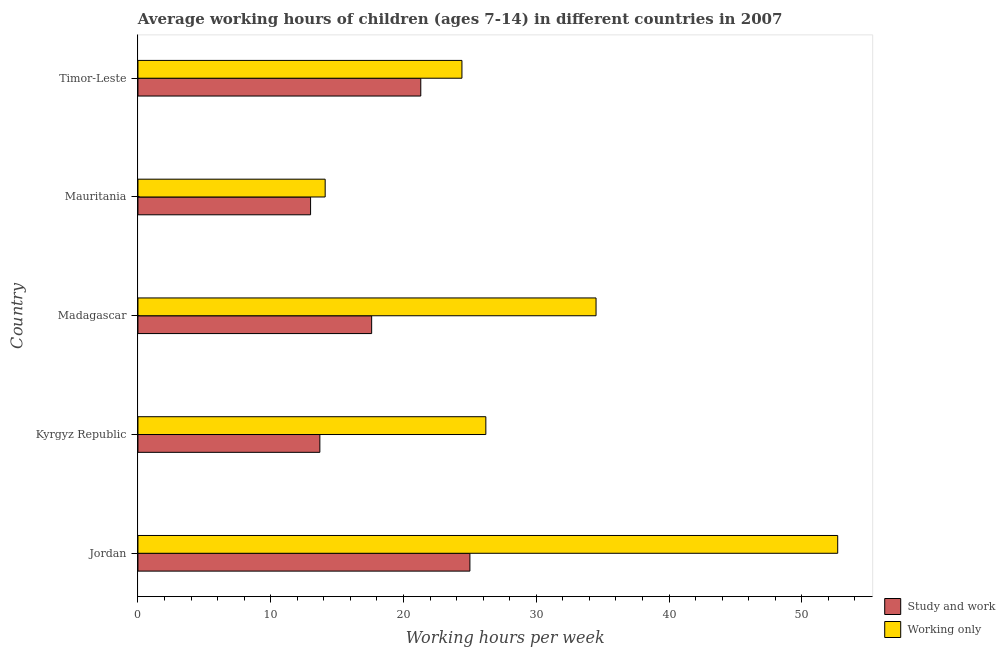How many different coloured bars are there?
Ensure brevity in your answer.  2. How many groups of bars are there?
Ensure brevity in your answer.  5. Are the number of bars per tick equal to the number of legend labels?
Ensure brevity in your answer.  Yes. How many bars are there on the 3rd tick from the top?
Ensure brevity in your answer.  2. How many bars are there on the 3rd tick from the bottom?
Offer a very short reply. 2. What is the label of the 4th group of bars from the top?
Your answer should be compact. Kyrgyz Republic. What is the average working hour of children involved in study and work in Kyrgyz Republic?
Provide a short and direct response. 13.7. Across all countries, what is the maximum average working hour of children involved in only work?
Offer a very short reply. 52.7. In which country was the average working hour of children involved in study and work maximum?
Give a very brief answer. Jordan. In which country was the average working hour of children involved in study and work minimum?
Give a very brief answer. Mauritania. What is the total average working hour of children involved in only work in the graph?
Your response must be concise. 151.9. What is the difference between the average working hour of children involved in study and work in Kyrgyz Republic and the average working hour of children involved in only work in Timor-Leste?
Your answer should be compact. -10.7. What is the average average working hour of children involved in study and work per country?
Offer a terse response. 18.12. What is the difference between the average working hour of children involved in study and work and average working hour of children involved in only work in Jordan?
Your response must be concise. -27.7. In how many countries, is the average working hour of children involved in only work greater than 6 hours?
Provide a succinct answer. 5. What is the ratio of the average working hour of children involved in study and work in Jordan to that in Timor-Leste?
Offer a terse response. 1.17. Is the difference between the average working hour of children involved in only work in Madagascar and Mauritania greater than the difference between the average working hour of children involved in study and work in Madagascar and Mauritania?
Give a very brief answer. Yes. What is the difference between the highest and the second highest average working hour of children involved in study and work?
Offer a very short reply. 3.7. What is the difference between the highest and the lowest average working hour of children involved in only work?
Make the answer very short. 38.6. What does the 2nd bar from the top in Timor-Leste represents?
Keep it short and to the point. Study and work. What does the 2nd bar from the bottom in Jordan represents?
Keep it short and to the point. Working only. How many bars are there?
Your answer should be compact. 10. How many countries are there in the graph?
Offer a very short reply. 5. What is the difference between two consecutive major ticks on the X-axis?
Provide a succinct answer. 10. Are the values on the major ticks of X-axis written in scientific E-notation?
Your answer should be very brief. No. Does the graph contain any zero values?
Make the answer very short. No. How are the legend labels stacked?
Provide a succinct answer. Vertical. What is the title of the graph?
Provide a short and direct response. Average working hours of children (ages 7-14) in different countries in 2007. What is the label or title of the X-axis?
Keep it short and to the point. Working hours per week. What is the Working hours per week in Study and work in Jordan?
Keep it short and to the point. 25. What is the Working hours per week of Working only in Jordan?
Provide a succinct answer. 52.7. What is the Working hours per week of Working only in Kyrgyz Republic?
Ensure brevity in your answer.  26.2. What is the Working hours per week in Study and work in Madagascar?
Keep it short and to the point. 17.6. What is the Working hours per week of Working only in Madagascar?
Provide a succinct answer. 34.5. What is the Working hours per week of Working only in Mauritania?
Ensure brevity in your answer.  14.1. What is the Working hours per week of Study and work in Timor-Leste?
Your answer should be very brief. 21.3. What is the Working hours per week in Working only in Timor-Leste?
Offer a terse response. 24.4. Across all countries, what is the maximum Working hours per week in Study and work?
Your answer should be compact. 25. Across all countries, what is the maximum Working hours per week in Working only?
Offer a terse response. 52.7. Across all countries, what is the minimum Working hours per week in Working only?
Your answer should be compact. 14.1. What is the total Working hours per week in Study and work in the graph?
Your answer should be very brief. 90.6. What is the total Working hours per week of Working only in the graph?
Keep it short and to the point. 151.9. What is the difference between the Working hours per week of Working only in Jordan and that in Kyrgyz Republic?
Your answer should be very brief. 26.5. What is the difference between the Working hours per week in Study and work in Jordan and that in Mauritania?
Make the answer very short. 12. What is the difference between the Working hours per week of Working only in Jordan and that in Mauritania?
Give a very brief answer. 38.6. What is the difference between the Working hours per week in Working only in Jordan and that in Timor-Leste?
Offer a very short reply. 28.3. What is the difference between the Working hours per week of Working only in Kyrgyz Republic and that in Madagascar?
Your answer should be compact. -8.3. What is the difference between the Working hours per week in Working only in Kyrgyz Republic and that in Mauritania?
Ensure brevity in your answer.  12.1. What is the difference between the Working hours per week of Study and work in Kyrgyz Republic and that in Timor-Leste?
Your answer should be compact. -7.6. What is the difference between the Working hours per week in Working only in Kyrgyz Republic and that in Timor-Leste?
Give a very brief answer. 1.8. What is the difference between the Working hours per week of Study and work in Madagascar and that in Mauritania?
Provide a succinct answer. 4.6. What is the difference between the Working hours per week of Working only in Madagascar and that in Mauritania?
Your response must be concise. 20.4. What is the difference between the Working hours per week in Study and work in Madagascar and that in Timor-Leste?
Keep it short and to the point. -3.7. What is the difference between the Working hours per week in Working only in Madagascar and that in Timor-Leste?
Give a very brief answer. 10.1. What is the difference between the Working hours per week in Study and work in Mauritania and that in Timor-Leste?
Offer a terse response. -8.3. What is the difference between the Working hours per week of Working only in Mauritania and that in Timor-Leste?
Your response must be concise. -10.3. What is the difference between the Working hours per week in Study and work in Jordan and the Working hours per week in Working only in Kyrgyz Republic?
Provide a succinct answer. -1.2. What is the difference between the Working hours per week of Study and work in Jordan and the Working hours per week of Working only in Madagascar?
Provide a short and direct response. -9.5. What is the difference between the Working hours per week of Study and work in Jordan and the Working hours per week of Working only in Timor-Leste?
Provide a short and direct response. 0.6. What is the difference between the Working hours per week in Study and work in Kyrgyz Republic and the Working hours per week in Working only in Madagascar?
Give a very brief answer. -20.8. What is the difference between the Working hours per week in Study and work in Madagascar and the Working hours per week in Working only in Mauritania?
Your answer should be compact. 3.5. What is the difference between the Working hours per week in Study and work in Madagascar and the Working hours per week in Working only in Timor-Leste?
Give a very brief answer. -6.8. What is the average Working hours per week in Study and work per country?
Your response must be concise. 18.12. What is the average Working hours per week of Working only per country?
Offer a terse response. 30.38. What is the difference between the Working hours per week of Study and work and Working hours per week of Working only in Jordan?
Ensure brevity in your answer.  -27.7. What is the difference between the Working hours per week of Study and work and Working hours per week of Working only in Madagascar?
Your response must be concise. -16.9. What is the difference between the Working hours per week in Study and work and Working hours per week in Working only in Mauritania?
Make the answer very short. -1.1. What is the difference between the Working hours per week in Study and work and Working hours per week in Working only in Timor-Leste?
Your response must be concise. -3.1. What is the ratio of the Working hours per week of Study and work in Jordan to that in Kyrgyz Republic?
Your answer should be very brief. 1.82. What is the ratio of the Working hours per week in Working only in Jordan to that in Kyrgyz Republic?
Offer a terse response. 2.01. What is the ratio of the Working hours per week of Study and work in Jordan to that in Madagascar?
Provide a short and direct response. 1.42. What is the ratio of the Working hours per week of Working only in Jordan to that in Madagascar?
Offer a terse response. 1.53. What is the ratio of the Working hours per week of Study and work in Jordan to that in Mauritania?
Give a very brief answer. 1.92. What is the ratio of the Working hours per week of Working only in Jordan to that in Mauritania?
Make the answer very short. 3.74. What is the ratio of the Working hours per week in Study and work in Jordan to that in Timor-Leste?
Offer a terse response. 1.17. What is the ratio of the Working hours per week of Working only in Jordan to that in Timor-Leste?
Your answer should be very brief. 2.16. What is the ratio of the Working hours per week of Study and work in Kyrgyz Republic to that in Madagascar?
Offer a terse response. 0.78. What is the ratio of the Working hours per week in Working only in Kyrgyz Republic to that in Madagascar?
Offer a terse response. 0.76. What is the ratio of the Working hours per week of Study and work in Kyrgyz Republic to that in Mauritania?
Keep it short and to the point. 1.05. What is the ratio of the Working hours per week in Working only in Kyrgyz Republic to that in Mauritania?
Offer a terse response. 1.86. What is the ratio of the Working hours per week in Study and work in Kyrgyz Republic to that in Timor-Leste?
Your answer should be very brief. 0.64. What is the ratio of the Working hours per week of Working only in Kyrgyz Republic to that in Timor-Leste?
Offer a terse response. 1.07. What is the ratio of the Working hours per week of Study and work in Madagascar to that in Mauritania?
Provide a short and direct response. 1.35. What is the ratio of the Working hours per week in Working only in Madagascar to that in Mauritania?
Provide a succinct answer. 2.45. What is the ratio of the Working hours per week in Study and work in Madagascar to that in Timor-Leste?
Make the answer very short. 0.83. What is the ratio of the Working hours per week in Working only in Madagascar to that in Timor-Leste?
Give a very brief answer. 1.41. What is the ratio of the Working hours per week of Study and work in Mauritania to that in Timor-Leste?
Provide a short and direct response. 0.61. What is the ratio of the Working hours per week of Working only in Mauritania to that in Timor-Leste?
Provide a short and direct response. 0.58. What is the difference between the highest and the second highest Working hours per week in Working only?
Provide a succinct answer. 18.2. What is the difference between the highest and the lowest Working hours per week in Working only?
Ensure brevity in your answer.  38.6. 